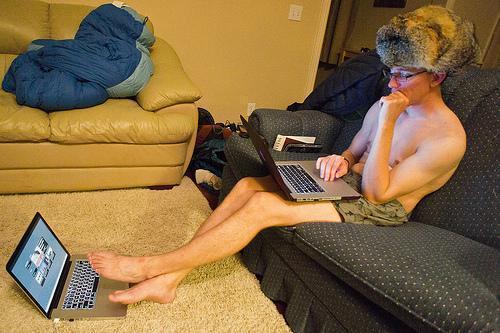How many people are in picture?
Give a very brief answer. 1. 